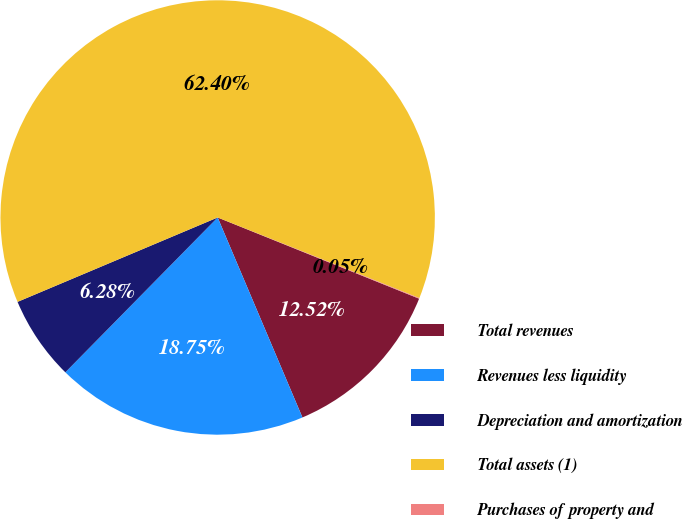Convert chart. <chart><loc_0><loc_0><loc_500><loc_500><pie_chart><fcel>Total revenues<fcel>Revenues less liquidity<fcel>Depreciation and amortization<fcel>Total assets (1)<fcel>Purchases of property and<nl><fcel>12.52%<fcel>18.75%<fcel>6.28%<fcel>62.4%<fcel>0.05%<nl></chart> 